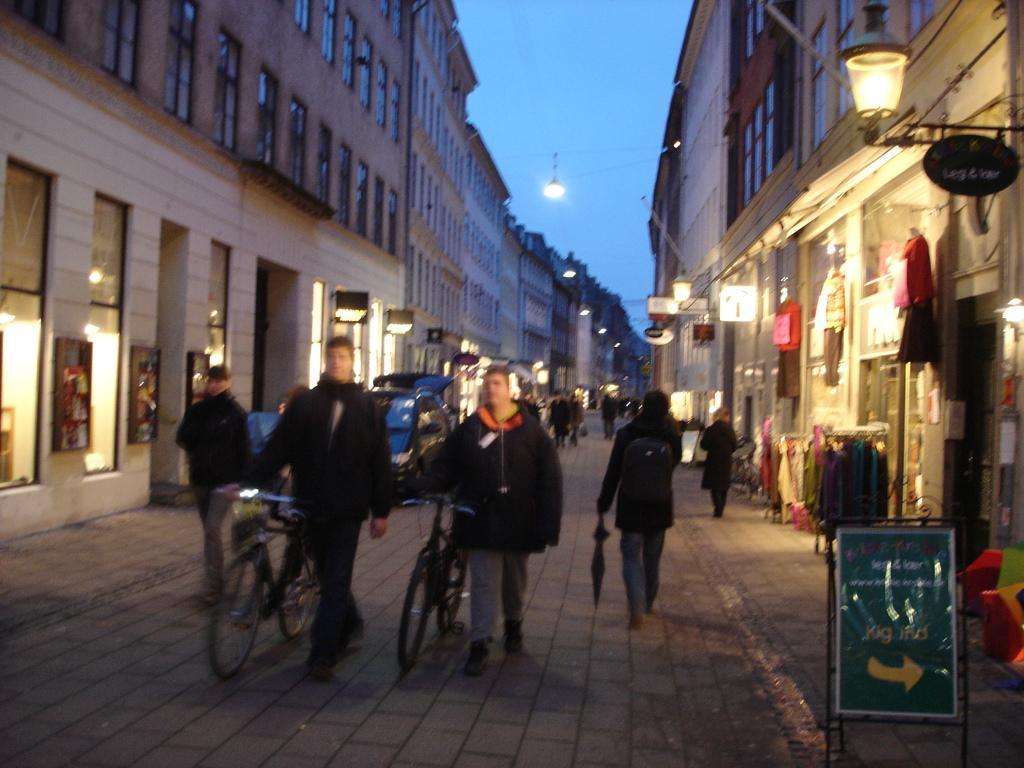Describe this image in one or two sentences. In this image we can see some people walking on the road. We can also see two people holding the bicycles, a car on the road and a person holding an umbrella. On the right side we can see some buildings with windows, a board, street poles and a person walking on the foot path. On the backside we can see some trees and the sky. 